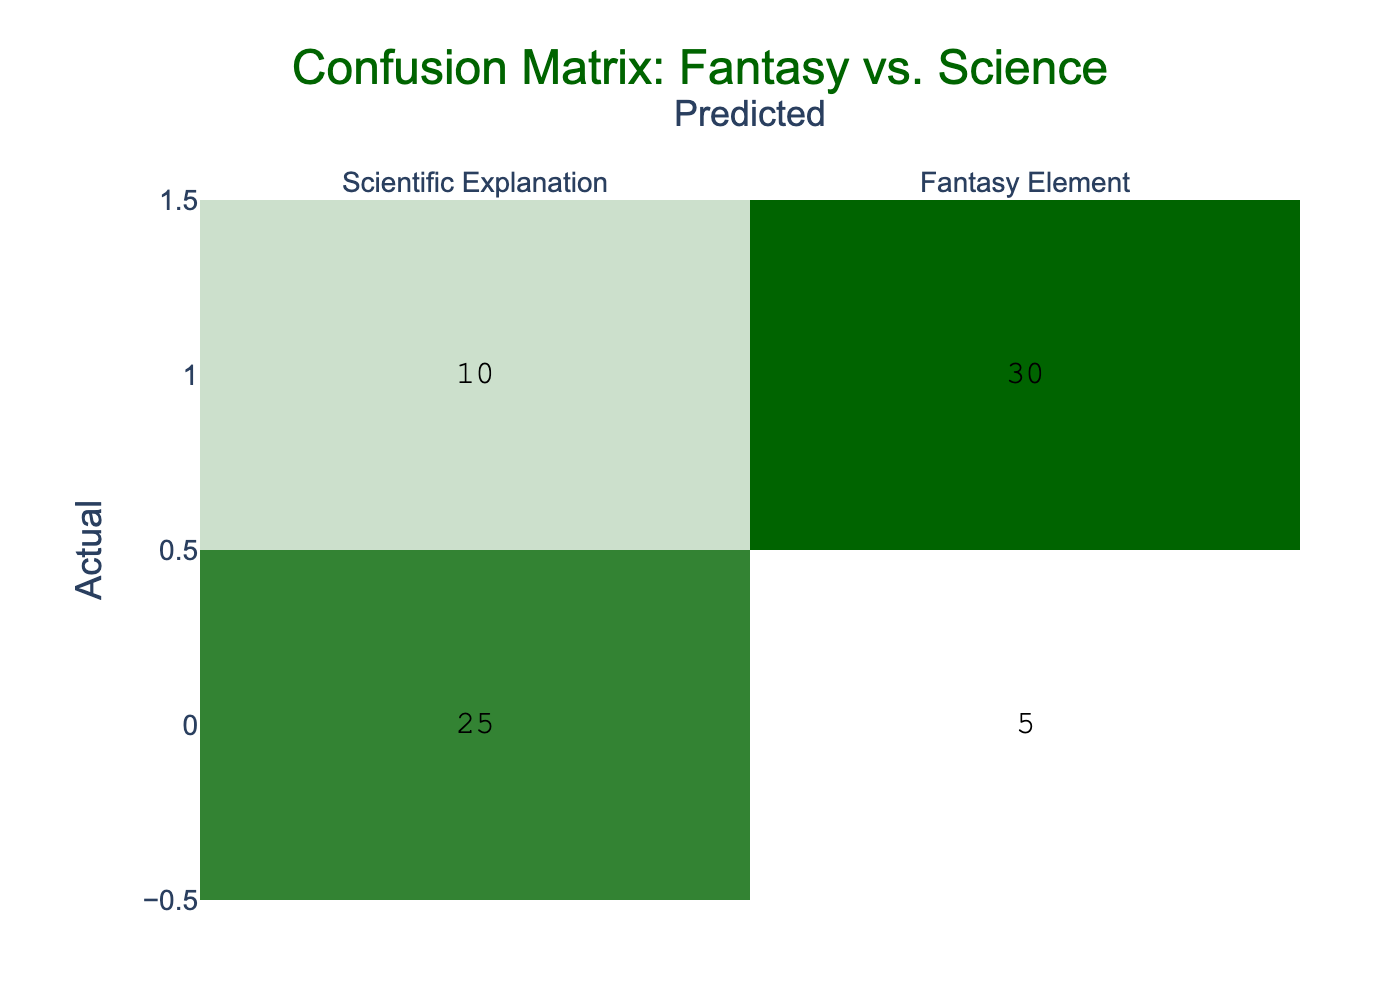What is the number of instances where a fantasy element was predicted as a scientific explanation? According to the table, the value in the cell for the actual category "Fantasy Element" and predicted category "Scientific Explanation" is 10.
Answer: 10 What is the total number of predictions made for scientific explanations? The total predictions for scientific explanations can be calculated by adding the counts in the "Scientific Explanation" column: 25 (correct) + 5 (incorrect) = 30.
Answer: 30 What is the number of instances where both actual and predicted categories were fantasy elements? From the table, the cell for actual category "Fantasy Element" and predicted category "Fantasy Element" shows a value of 30.
Answer: 30 Is it true that more instances were correctly identified as a scientific explanation than as a fantasy element? Yes, the actual values are 25 (scientific) compared to 30 (fantasy). Since 25 is less than 30, the statement is true.
Answer: Yes What is the difference between the number of fantasy elements correctly identified and the number of scientific explanations correctly identified? The correct identification for fantasy elements is 30, while for scientific explanations it is 25. The difference is 30 - 25 = 5.
Answer: 5 What percentage of the total predictions correspond to scientific explanations? The total predictions can be calculated by summing all the values in the table: 25 + 5 + 10 + 30 = 70. Then, for scientific explanations, 30 (correct + incorrect) divided by total predictions (70) gives us (30/70) * 100 = 42.86%.
Answer: 42.86% What is the total count of predictions that were incorrectly identified as a scientific explanation? The count of incorrect predictions for scientific explanations can be found in the cell for actual "Scientific Explanation" and predicted "Fantasy Element," which is 5.
Answer: 5 Which category had a higher number of incorrect predictions, scientific explanations or fantasy elements? The incorrect predictions for scientific explanations are 5, while for fantasy elements, we sum the correct prediction (30) and the incorrect (10), leading to 10 more being misclassified. Therefore, fantasy elements had higher incorrect predictions.
Answer: Fantasy Elements 